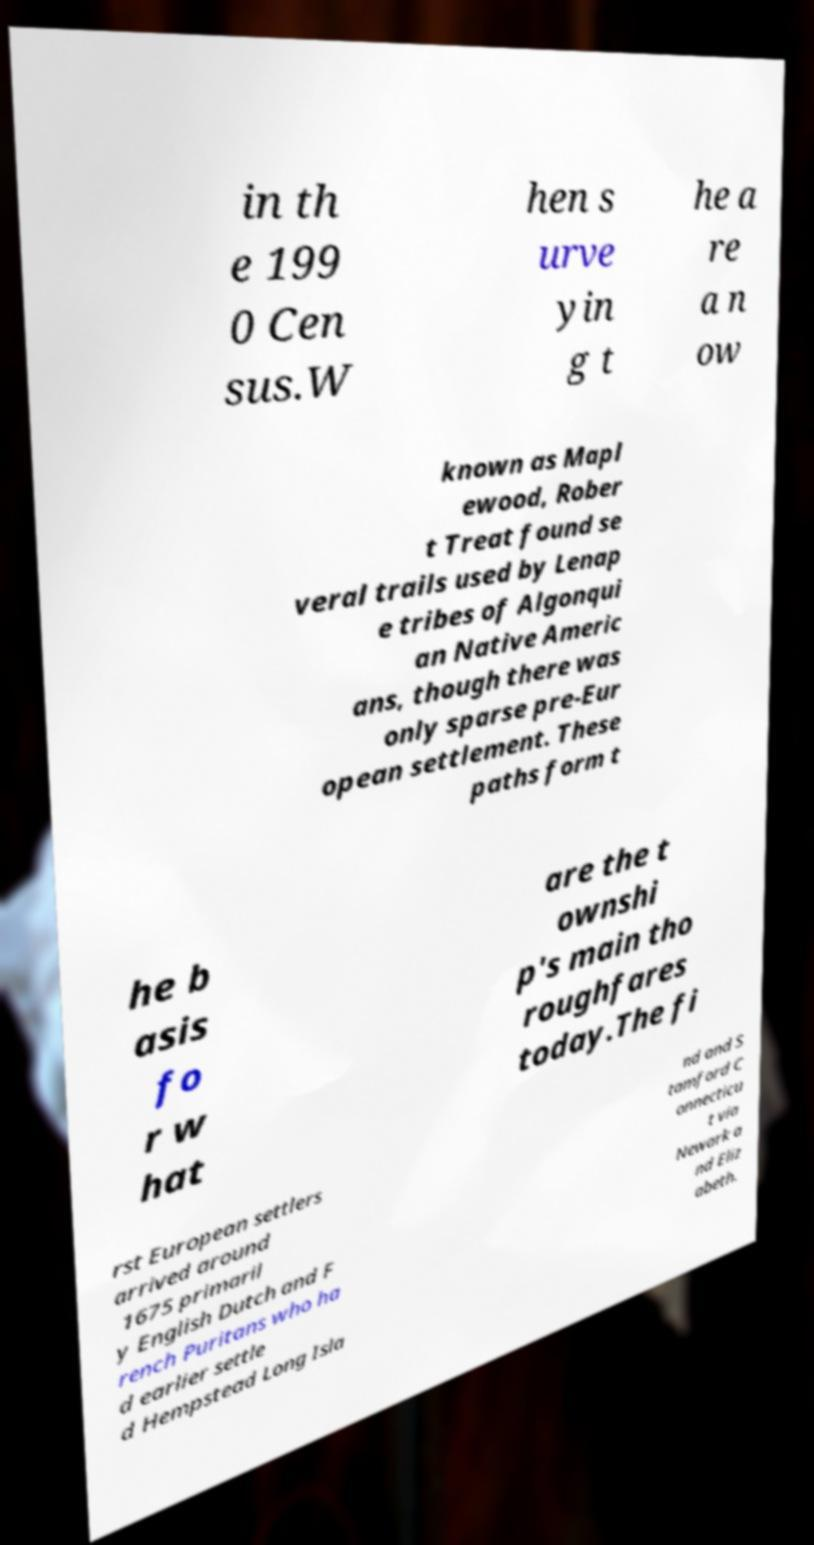Can you read and provide the text displayed in the image?This photo seems to have some interesting text. Can you extract and type it out for me? in th e 199 0 Cen sus.W hen s urve yin g t he a re a n ow known as Mapl ewood, Rober t Treat found se veral trails used by Lenap e tribes of Algonqui an Native Americ ans, though there was only sparse pre-Eur opean settlement. These paths form t he b asis fo r w hat are the t ownshi p's main tho roughfares today.The fi rst European settlers arrived around 1675 primaril y English Dutch and F rench Puritans who ha d earlier settle d Hempstead Long Isla nd and S tamford C onnecticu t via Newark a nd Eliz abeth. 